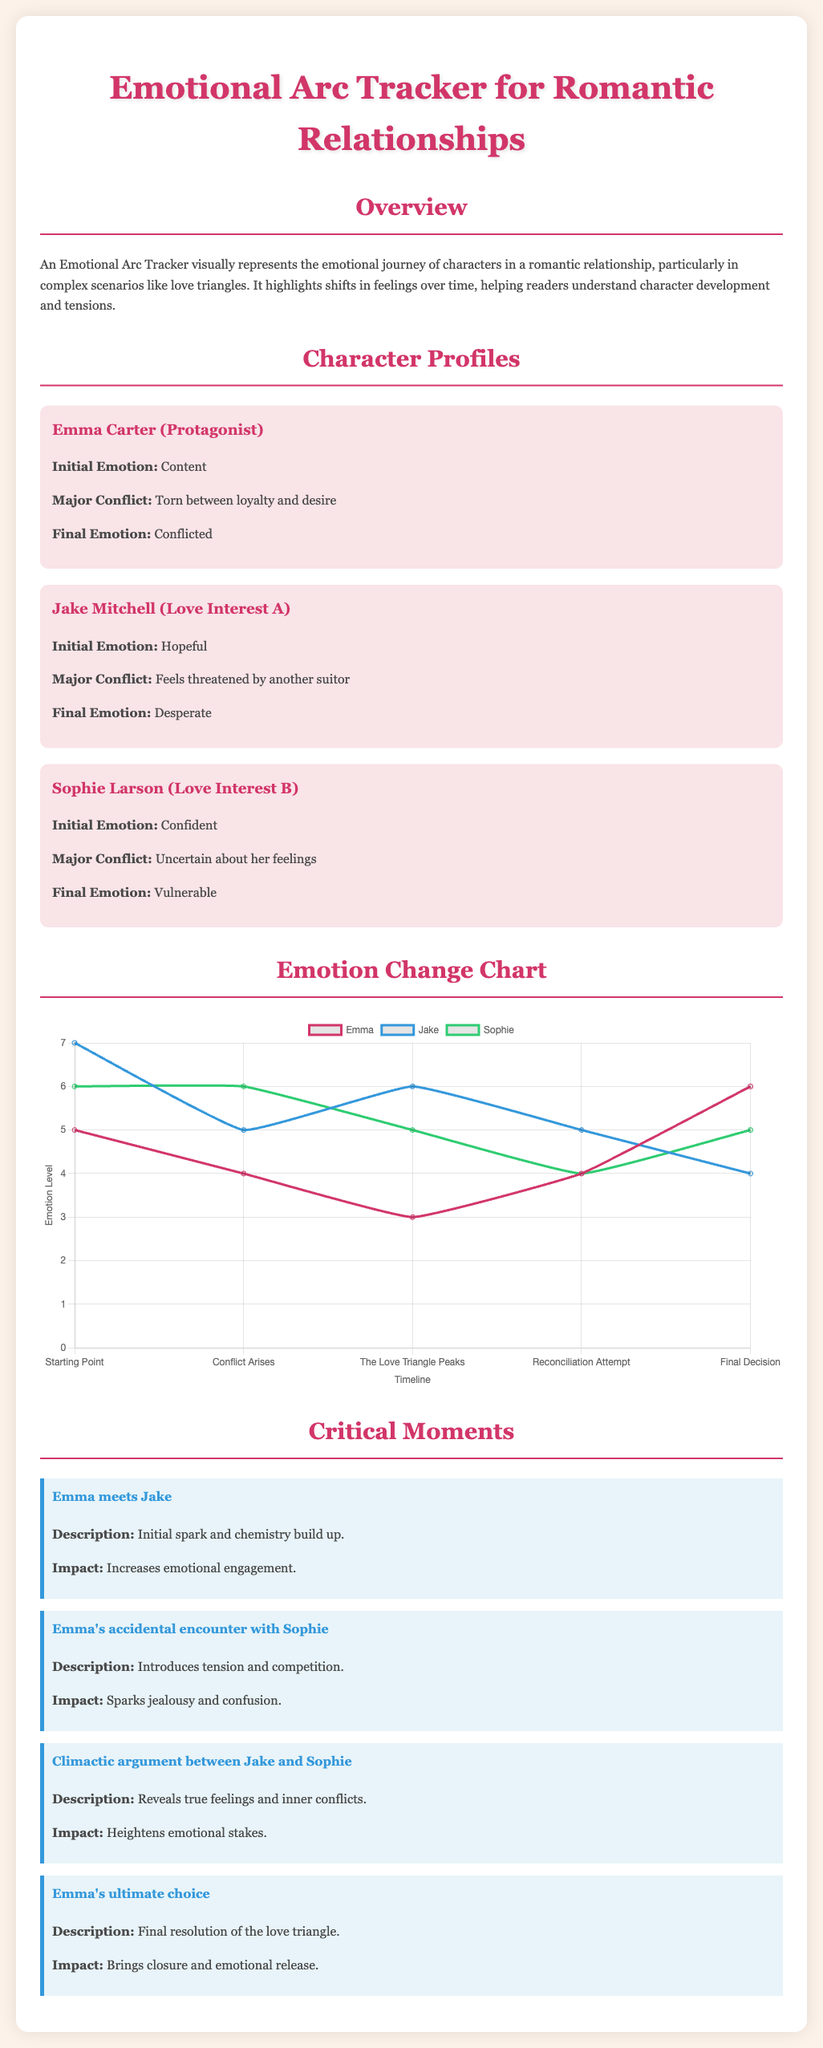What is Emma's initial emotion? Emma's initial emotion is described in her character profile as "Content."
Answer: Content What major conflict does Jake experience? The major conflict for Jake is mentioned as "Feels threatened by another suitor."
Answer: Feels threatened by another suitor What is the title of the document? The title is provided at the beginning of the document and is "Emotional Arc Tracker for Romantic Relationships."
Answer: Emotional Arc Tracker for Romantic Relationships What is the final emotion of Sophie? Sophie’s final emotion is stated in her profile as "Vulnerable."
Answer: Vulnerable What happens during the climactic argument? The description states that it "Reveals true feelings and inner conflicts."
Answer: Reveals true feelings and inner conflicts How many critical moments are described in the document? The number of critical moments is found by counting the sections detailed in the manual, which lists them explicitly.
Answer: Four What is the emotional level of Emma at the peak of the love triangle? The emotional level at the peak is represented in the chart, showing her data point at that moment.
Answer: Three What is the impact of Emma's ultimate choice? The impact is described as "Brings closure and emotional release."
Answer: Brings closure and emotional release 